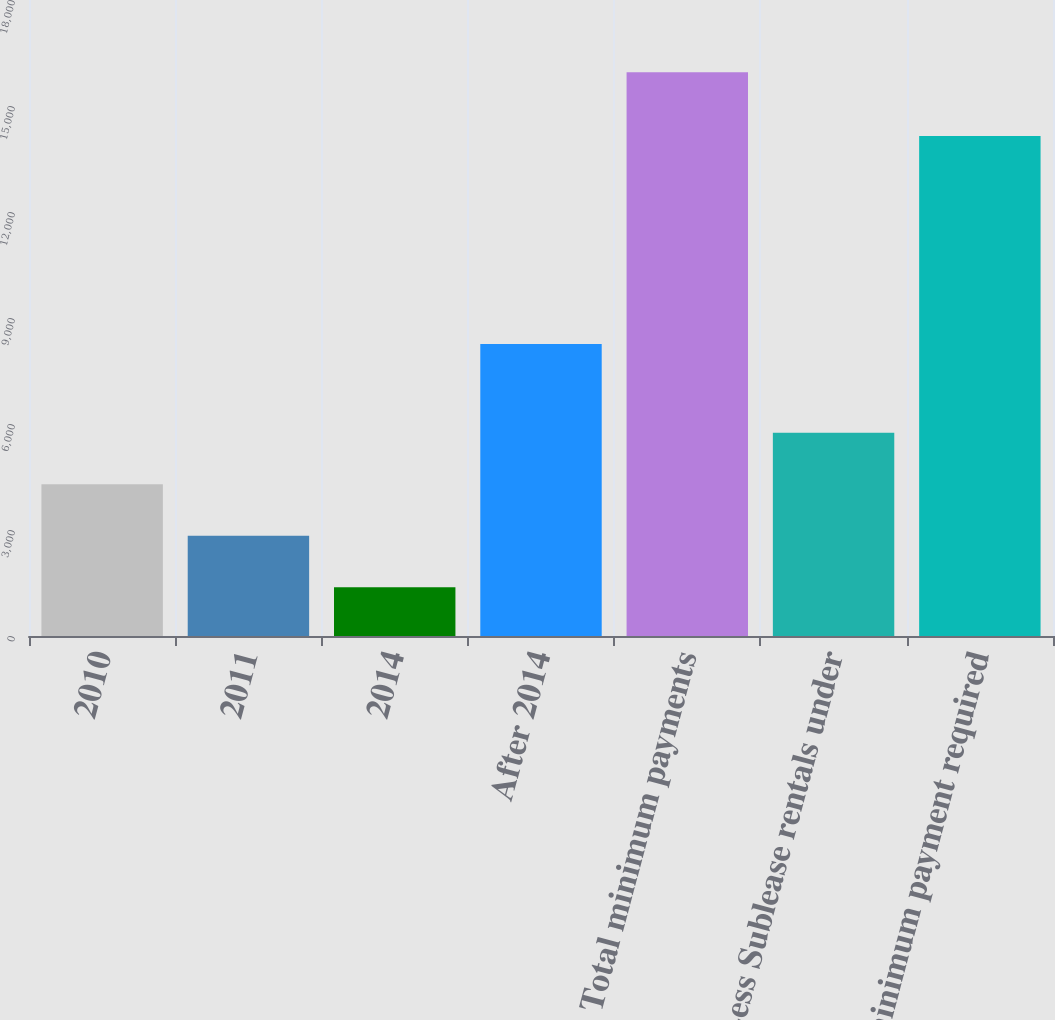Convert chart. <chart><loc_0><loc_0><loc_500><loc_500><bar_chart><fcel>2010<fcel>2011<fcel>2014<fcel>After 2014<fcel>Total minimum payments<fcel>Less Sublease rentals under<fcel>Net minimum payment required<nl><fcel>4293.6<fcel>2836.3<fcel>1379<fcel>8264<fcel>15952<fcel>5750.9<fcel>14152<nl></chart> 